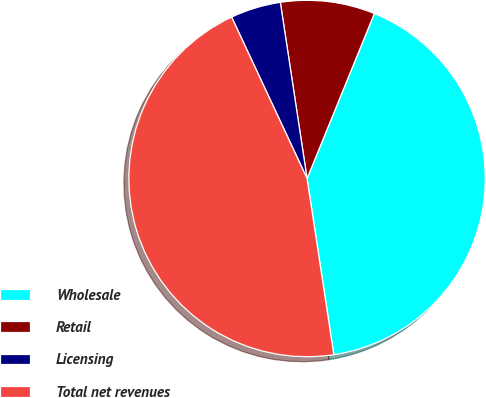Convert chart to OTSL. <chart><loc_0><loc_0><loc_500><loc_500><pie_chart><fcel>Wholesale<fcel>Retail<fcel>Licensing<fcel>Total net revenues<nl><fcel>41.44%<fcel>8.56%<fcel>4.56%<fcel>45.44%<nl></chart> 